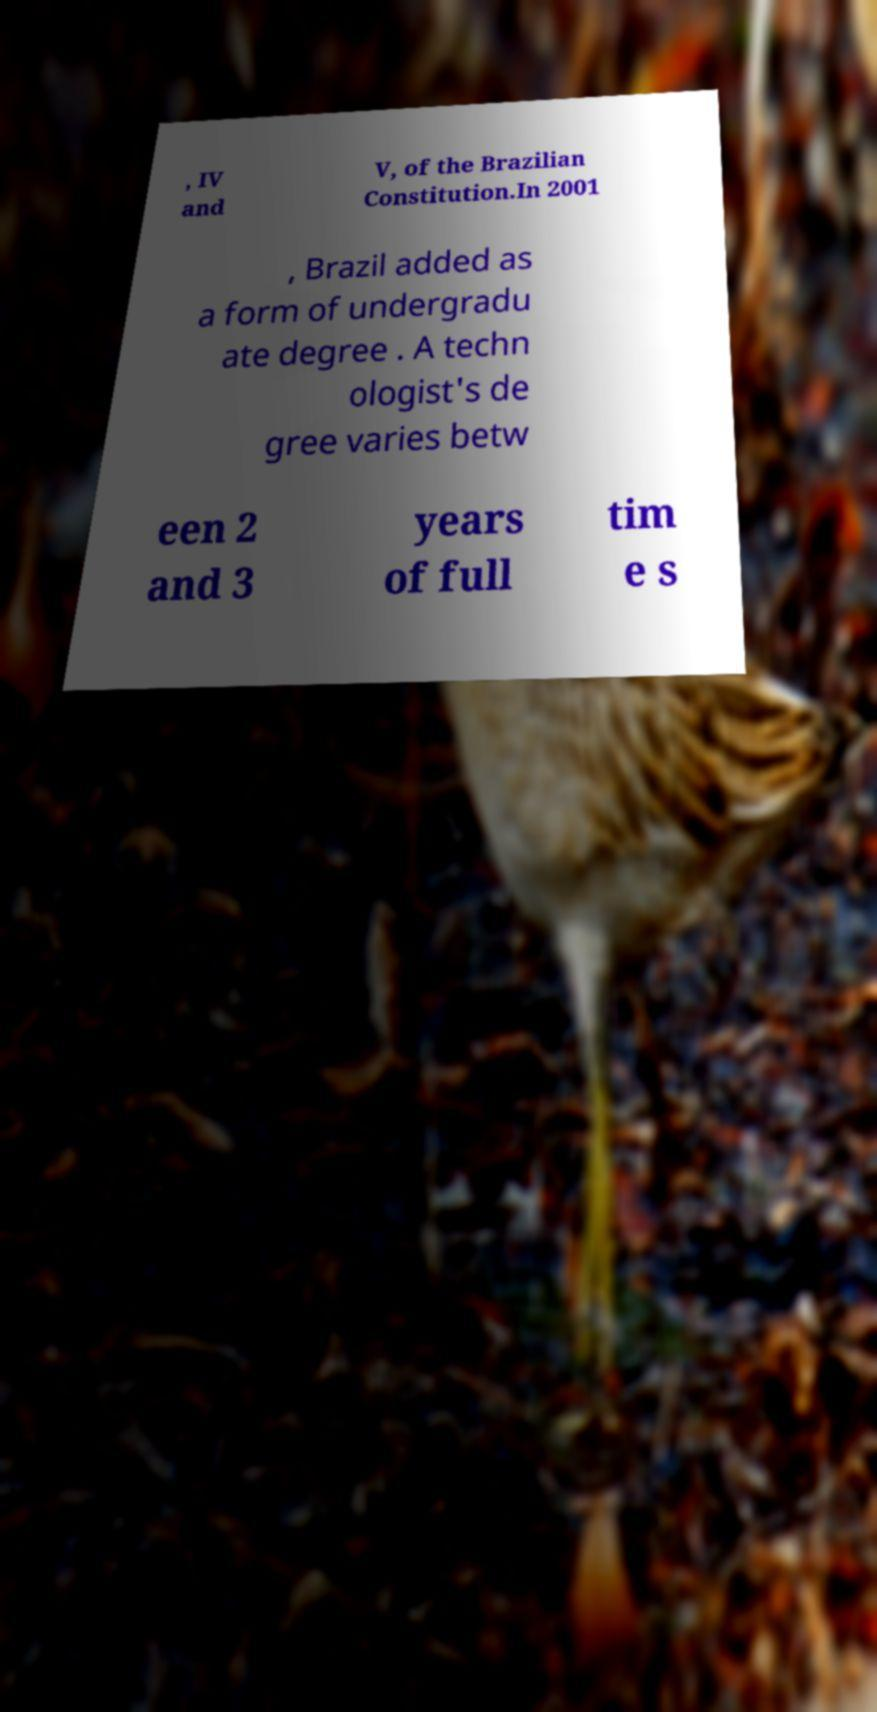Can you accurately transcribe the text from the provided image for me? , IV and V, of the Brazilian Constitution.In 2001 , Brazil added as a form of undergradu ate degree . A techn ologist's de gree varies betw een 2 and 3 years of full tim e s 